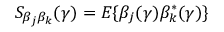<formula> <loc_0><loc_0><loc_500><loc_500>S _ { \beta _ { j } \beta _ { k } } ( \gamma ) = E \{ \beta _ { j } ( \gamma ) \beta _ { k } ^ { * } ( \gamma ) \}</formula> 